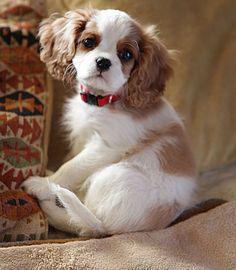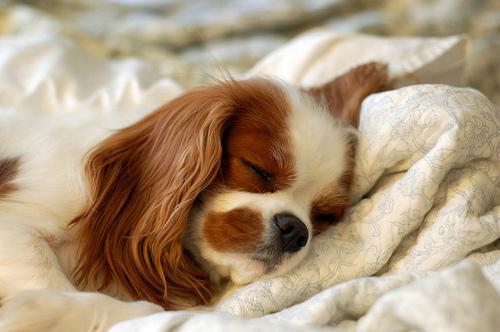The first image is the image on the left, the second image is the image on the right. Evaluate the accuracy of this statement regarding the images: "One of the puppies is laying the side of its head against a blanket.". Is it true? Answer yes or no. Yes. The first image is the image on the left, the second image is the image on the right. Examine the images to the left and right. Is the description "There are no more than four dogs." accurate? Answer yes or no. Yes. 